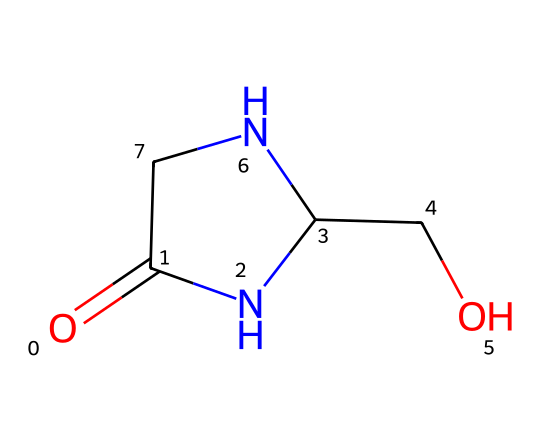What is the molecular formula of cycloserine? To determine the molecular formula, identify the number of each type of atom present in the SMILES. The SMILES representation contains one carbon (C) in the amide group, two nitrogen (N) atoms, two hydroxyl groups (O), and it totals to four carbons in the structure. Thus, the complete molecular formula is C3H6N2O2.
Answer: C3H6N2O2 How many rings are present in the structure of cycloserine? The SMILES shows a nitrogen-containing cyclic structure denoted by NC(CO) and surrounding carbon atoms, indicating there is one ring present in cycloserine.
Answer: 1 What functional groups are present in cycloserine? Looking at the SMILES, there is a carbonyl group (C=O) and two amine groups (N). The presence of -OH shows there are also hydroxyl groups (–OH) attached to the structure. Thus, cycloserine contains amine, carbonyl, and hydroxyl functional groups.
Answer: carbonyl, amine, hydroxyl What type of chemical is cycloserine classified as? Given the presence of a cyclized structure and multiple nitrogen atoms, as well as its use as an antibiotic, cycloserine is classified as a cyclic beta-amino acid.
Answer: cyclic beta-amino acid How many total atoms are in the cycloserine structure? By counting all the atoms in the SMILES, we have three carbon atoms, six hydrogen atoms, two nitrogen atoms, and two oxygen atoms which totals up to 13 atoms in total within cycloserine.
Answer: 13 How many chirality centers are in cycloserine? The structure displays a single chiral center where a carbon is attached to four different groups, indicating there is one chirality center present in cycloserine.
Answer: 1 